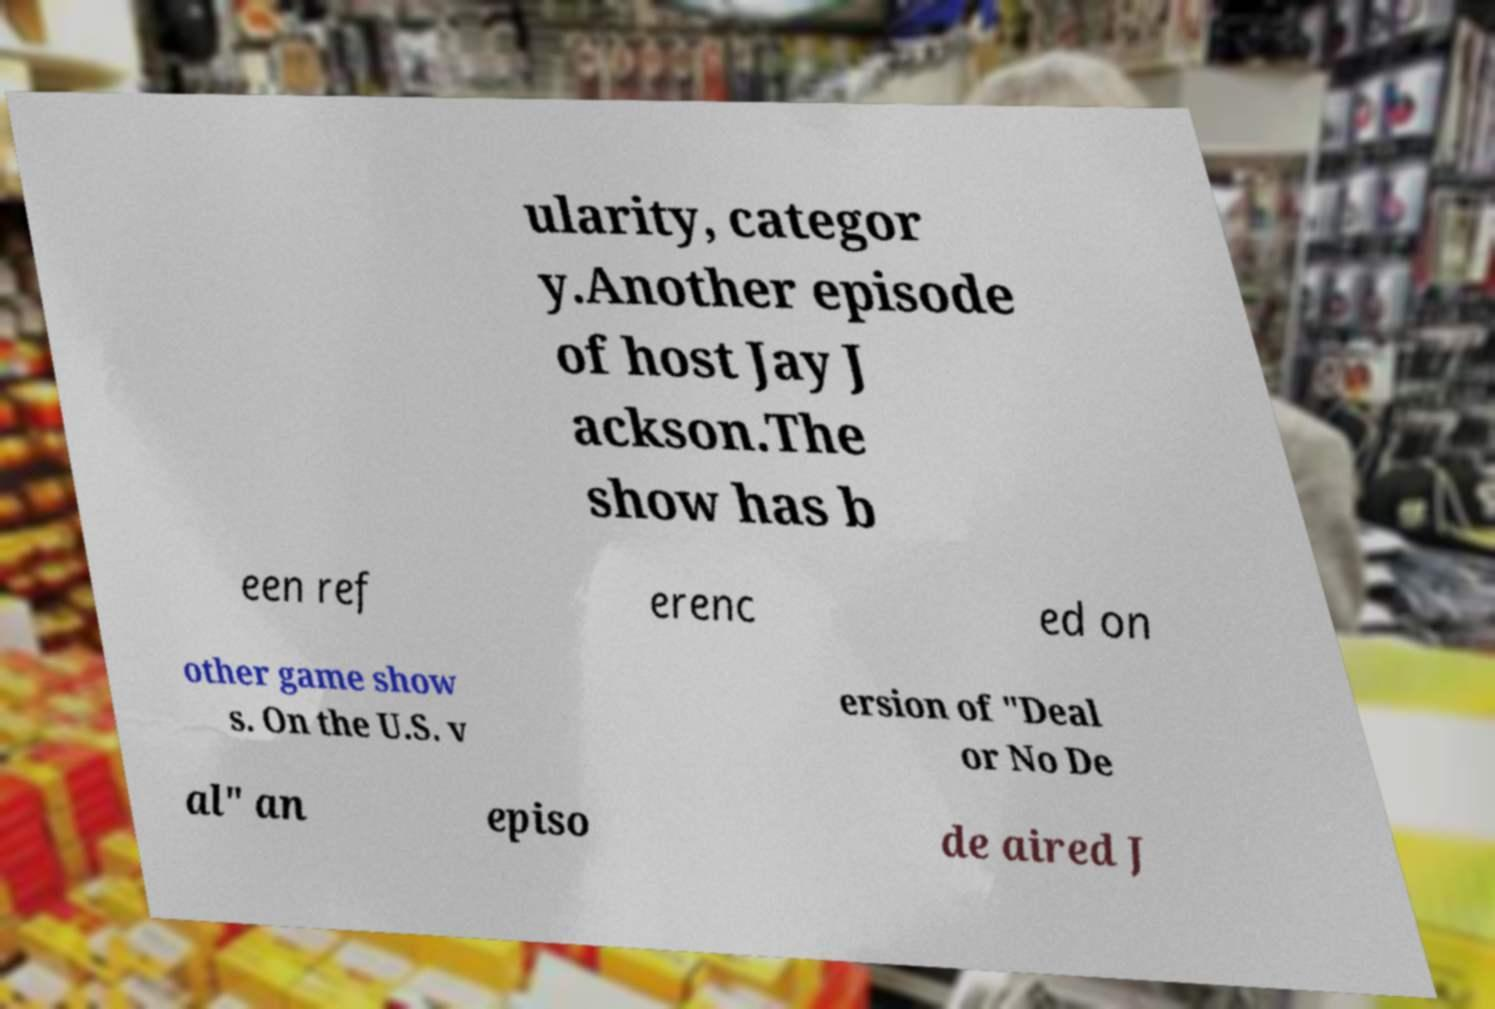I need the written content from this picture converted into text. Can you do that? ularity, categor y.Another episode of host Jay J ackson.The show has b een ref erenc ed on other game show s. On the U.S. v ersion of "Deal or No De al" an episo de aired J 